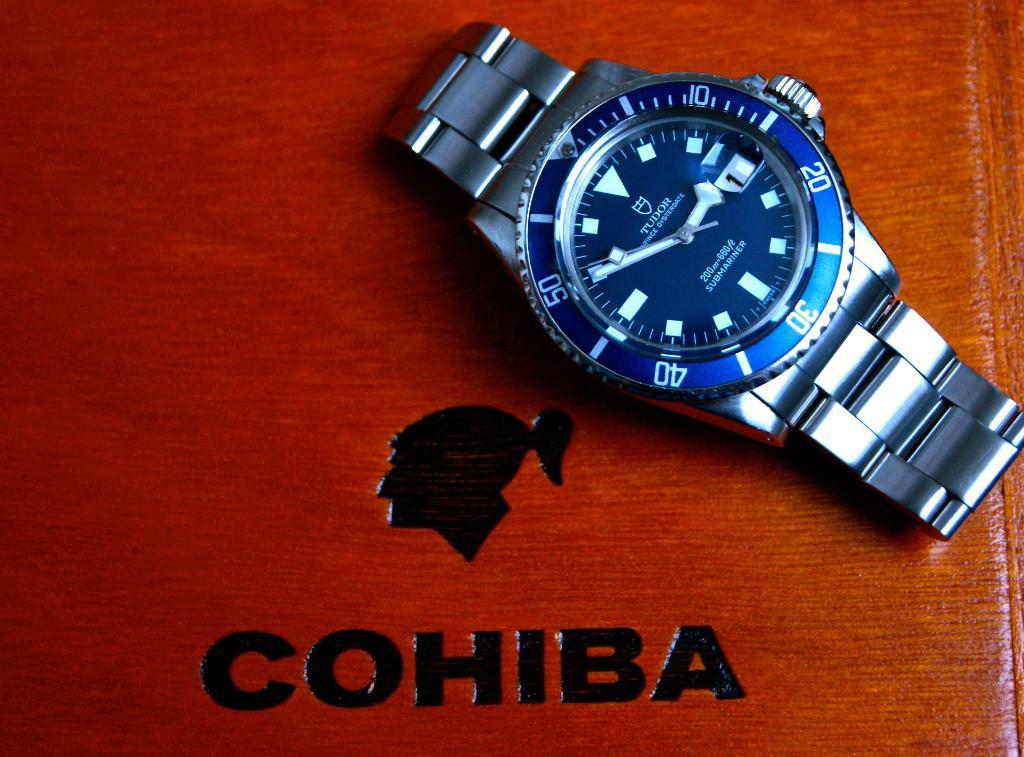<image>
Give a short and clear explanation of the subsequent image. A silver Tudor watch is sitting on a wooden Cohiba box. 